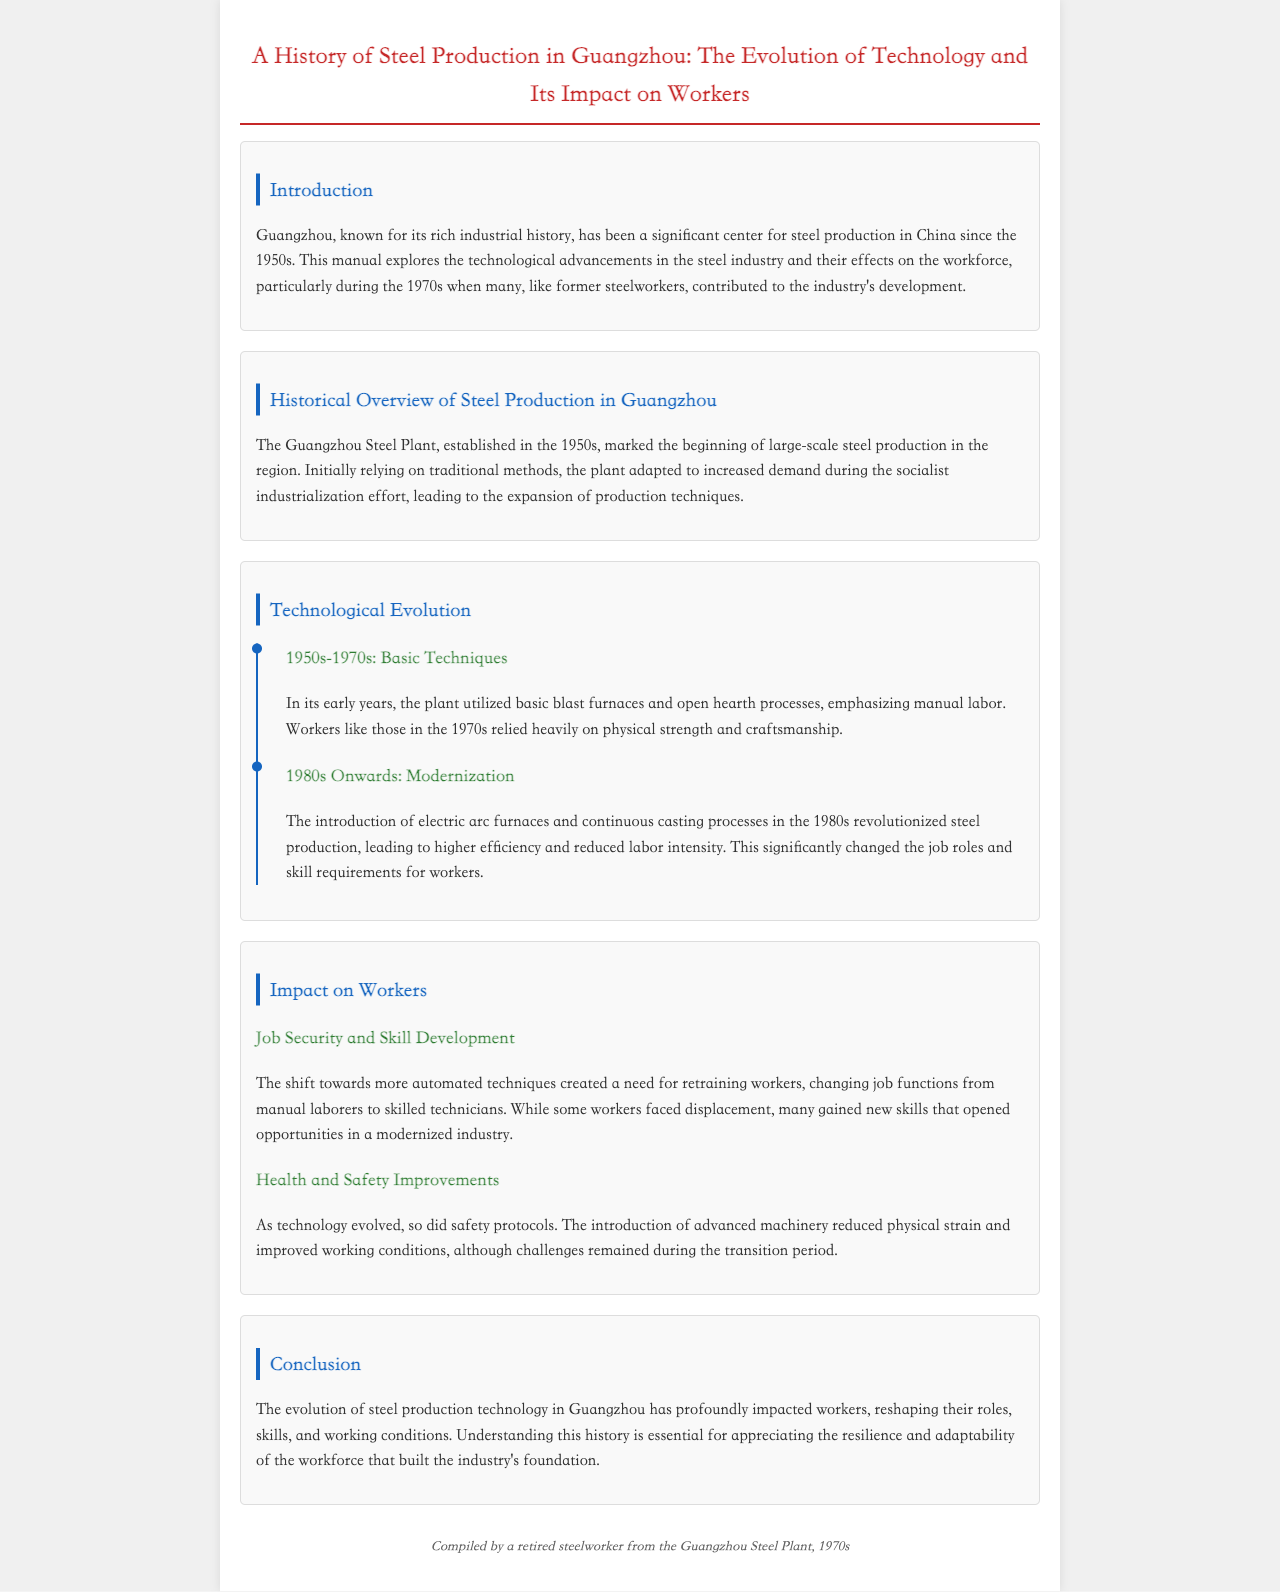what decade did large-scale steel production begin in Guangzhou? The document states that large-scale steel production in Guangzhou began in the 1950s.
Answer: 1950s what process was primarily used in the early years of the Guangzhou Steel Plant? The document mentions that the early years of the plant utilized basic blast furnaces and open hearth processes.
Answer: blast furnaces and open hearth processes which technological advancement was introduced in the 1980s? The document indicates that electric arc furnaces and continuous casting processes were introduced in the 1980s.
Answer: electric arc furnaces and continuous casting processes what major change occurred in worker roles due to modernization? The manual explains that workers moved from manual laborers to skilled technicians due to modernization.
Answer: skilled technicians what aspect of worker well-being improved with the introduction of advanced machinery? The document states that health and safety improvements were achieved as advanced machinery was introduced.
Answer: health and safety improvements what was a significant impact of technology evolution on job functions? The document describes that the shift to automated techniques required retraining workers and changed their job functions.
Answer: retraining workers how did worker job security change during the transition to modern techniques? The document notes that while some workers faced displacement, many gained new skills and opportunities.
Answer: displacement and new skills which year range marked the basic techniques phase in the steel plant's timeline? The document specifies that the period for basic techniques was from the 1950s to 1970s.
Answer: 1950s-1970s 